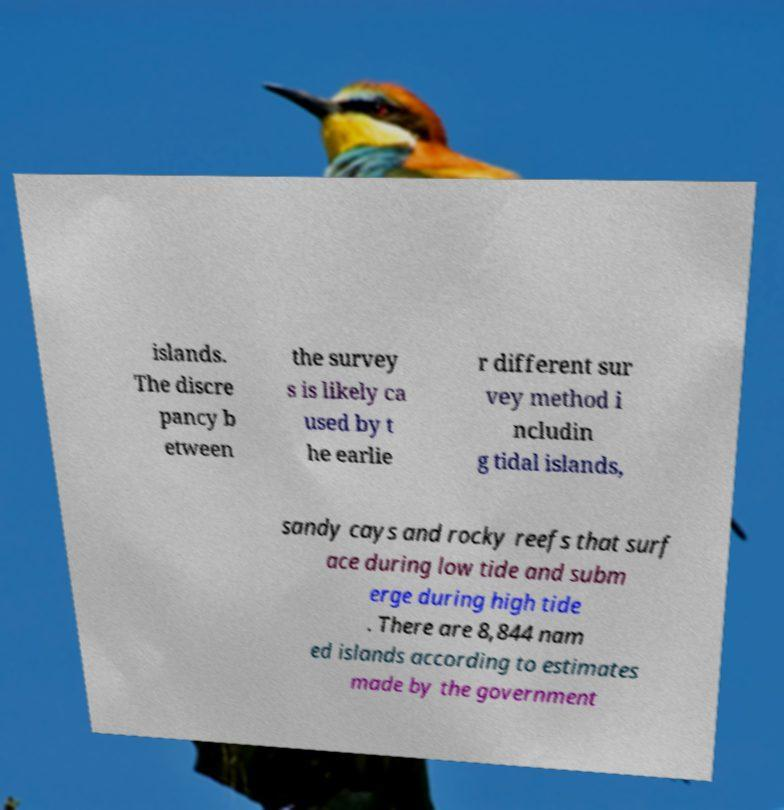Please identify and transcribe the text found in this image. islands. The discre pancy b etween the survey s is likely ca used by t he earlie r different sur vey method i ncludin g tidal islands, sandy cays and rocky reefs that surf ace during low tide and subm erge during high tide . There are 8,844 nam ed islands according to estimates made by the government 